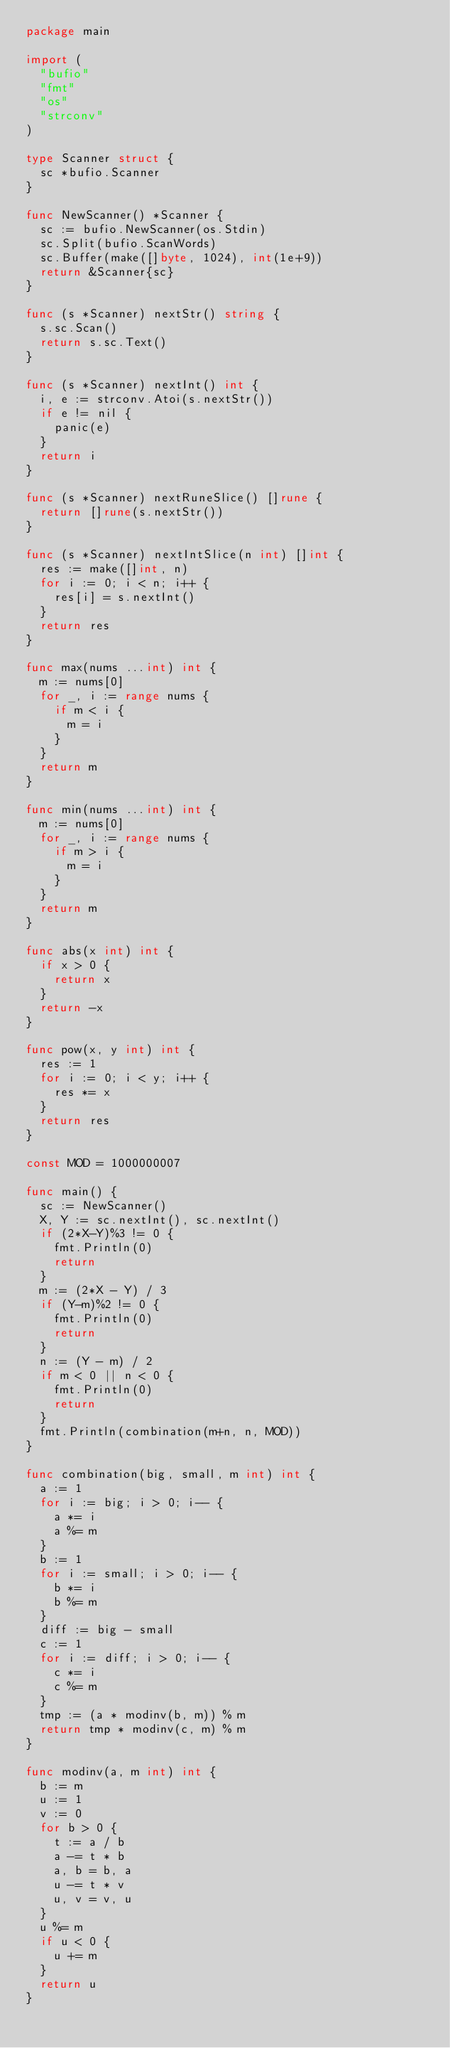<code> <loc_0><loc_0><loc_500><loc_500><_Go_>package main

import (
	"bufio"
	"fmt"
	"os"
	"strconv"
)

type Scanner struct {
	sc *bufio.Scanner
}

func NewScanner() *Scanner {
	sc := bufio.NewScanner(os.Stdin)
	sc.Split(bufio.ScanWords)
	sc.Buffer(make([]byte, 1024), int(1e+9))
	return &Scanner{sc}
}

func (s *Scanner) nextStr() string {
	s.sc.Scan()
	return s.sc.Text()
}

func (s *Scanner) nextInt() int {
	i, e := strconv.Atoi(s.nextStr())
	if e != nil {
		panic(e)
	}
	return i
}

func (s *Scanner) nextRuneSlice() []rune {
	return []rune(s.nextStr())
}

func (s *Scanner) nextIntSlice(n int) []int {
	res := make([]int, n)
	for i := 0; i < n; i++ {
		res[i] = s.nextInt()
	}
	return res
}

func max(nums ...int) int {
	m := nums[0]
	for _, i := range nums {
		if m < i {
			m = i
		}
	}
	return m
}

func min(nums ...int) int {
	m := nums[0]
	for _, i := range nums {
		if m > i {
			m = i
		}
	}
	return m
}

func abs(x int) int {
	if x > 0 {
		return x
	}
	return -x
}

func pow(x, y int) int {
	res := 1
	for i := 0; i < y; i++ {
		res *= x
	}
	return res
}

const MOD = 1000000007

func main() {
	sc := NewScanner()
	X, Y := sc.nextInt(), sc.nextInt()
	if (2*X-Y)%3 != 0 {
		fmt.Println(0)
		return
	}
	m := (2*X - Y) / 3
	if (Y-m)%2 != 0 {
		fmt.Println(0)
		return
	}
	n := (Y - m) / 2
	if m < 0 || n < 0 {
		fmt.Println(0)
		return
	}
	fmt.Println(combination(m+n, n, MOD))
}

func combination(big, small, m int) int {
	a := 1
	for i := big; i > 0; i-- {
		a *= i
		a %= m
	}
	b := 1
	for i := small; i > 0; i-- {
		b *= i
		b %= m
	}
	diff := big - small
	c := 1
	for i := diff; i > 0; i-- {
		c *= i
		c %= m
	}
	tmp := (a * modinv(b, m)) % m
	return tmp * modinv(c, m) % m
}

func modinv(a, m int) int {
	b := m
	u := 1
	v := 0
	for b > 0 {
		t := a / b
		a -= t * b
		a, b = b, a
		u -= t * v
		u, v = v, u
	}
	u %= m
	if u < 0 {
		u += m
	}
	return u
}
</code> 